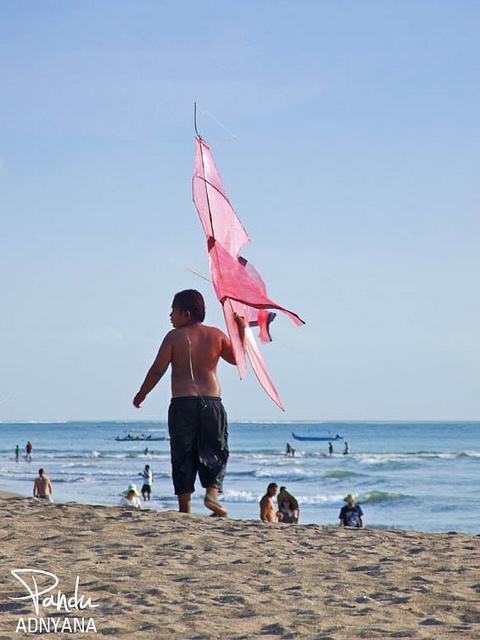How many sheep are in sunlight?
Give a very brief answer. 0. 